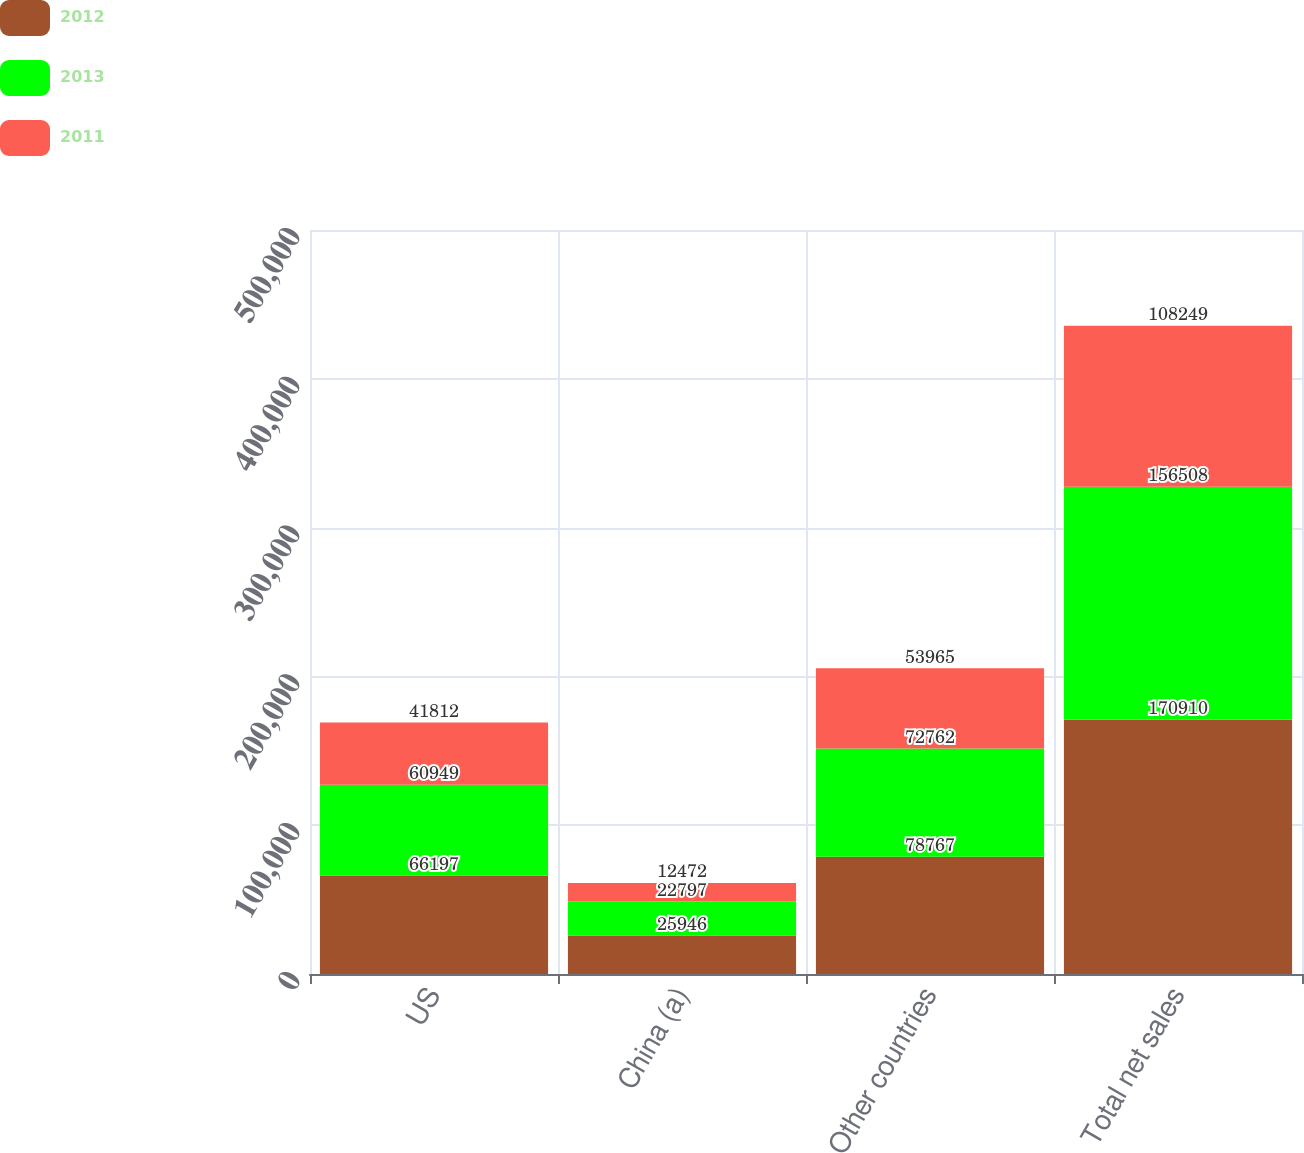Convert chart. <chart><loc_0><loc_0><loc_500><loc_500><stacked_bar_chart><ecel><fcel>US<fcel>China (a)<fcel>Other countries<fcel>Total net sales<nl><fcel>2012<fcel>66197<fcel>25946<fcel>78767<fcel>170910<nl><fcel>2013<fcel>60949<fcel>22797<fcel>72762<fcel>156508<nl><fcel>2011<fcel>41812<fcel>12472<fcel>53965<fcel>108249<nl></chart> 